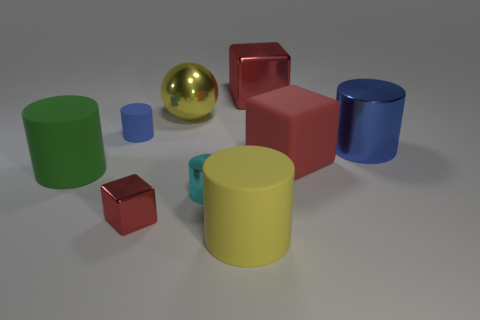What number of other objects are the same size as the yellow cylinder?
Your answer should be very brief. 5. What is the color of the big metal cube?
Offer a very short reply. Red. Are there any blue rubber objects?
Your answer should be compact. Yes. There is a yellow rubber cylinder; are there any big things behind it?
Ensure brevity in your answer.  Yes. There is a big yellow thing that is the same shape as the tiny cyan shiny object; what is its material?
Your answer should be compact. Rubber. What number of other things are there of the same shape as the tiny cyan metallic thing?
Your answer should be compact. 4. How many rubber blocks are in front of the blue object on the left side of the large rubber cylinder in front of the small red object?
Your answer should be compact. 1. How many yellow rubber objects are the same shape as the cyan shiny thing?
Your response must be concise. 1. There is a block behind the tiny blue matte thing; does it have the same color as the matte block?
Offer a terse response. Yes. What is the shape of the large matte object to the left of the big yellow object that is in front of the rubber cylinder behind the large blue metal object?
Provide a short and direct response. Cylinder. 